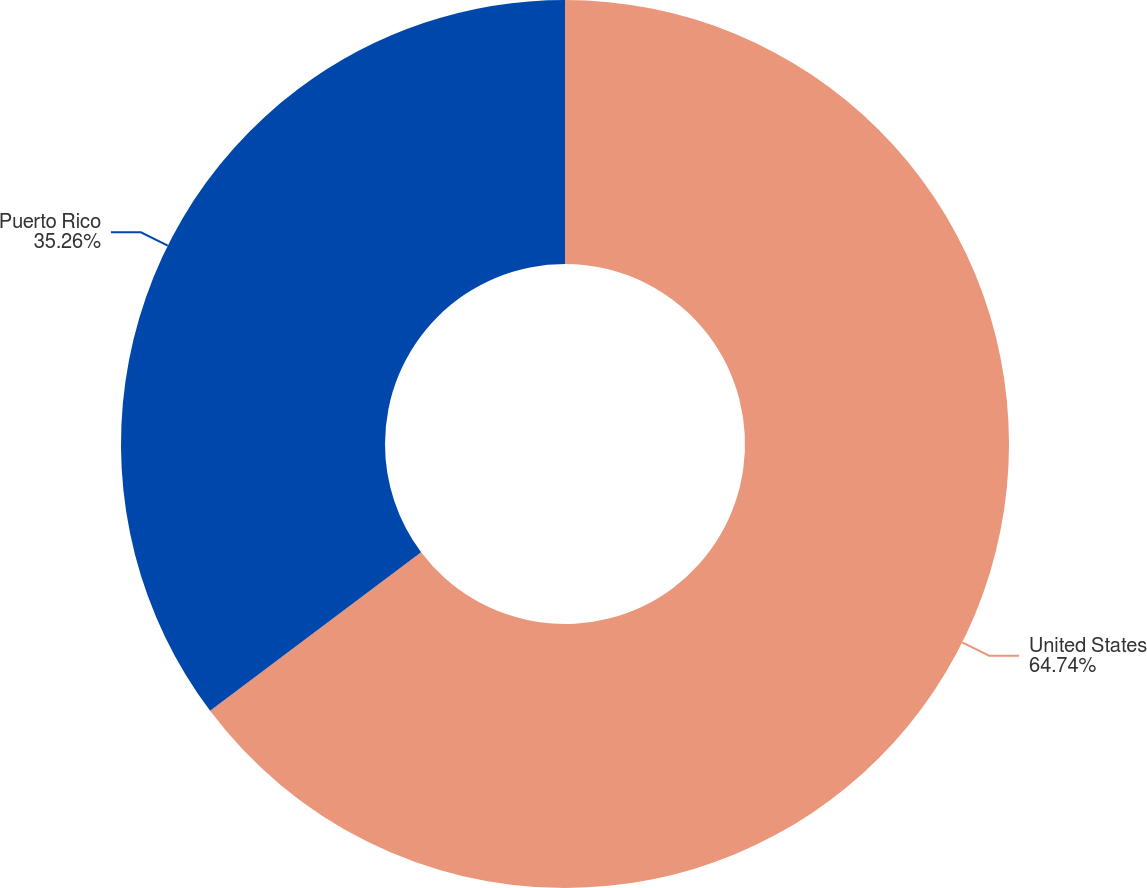<chart> <loc_0><loc_0><loc_500><loc_500><pie_chart><fcel>United States<fcel>Puerto Rico<nl><fcel>64.74%<fcel>35.26%<nl></chart> 